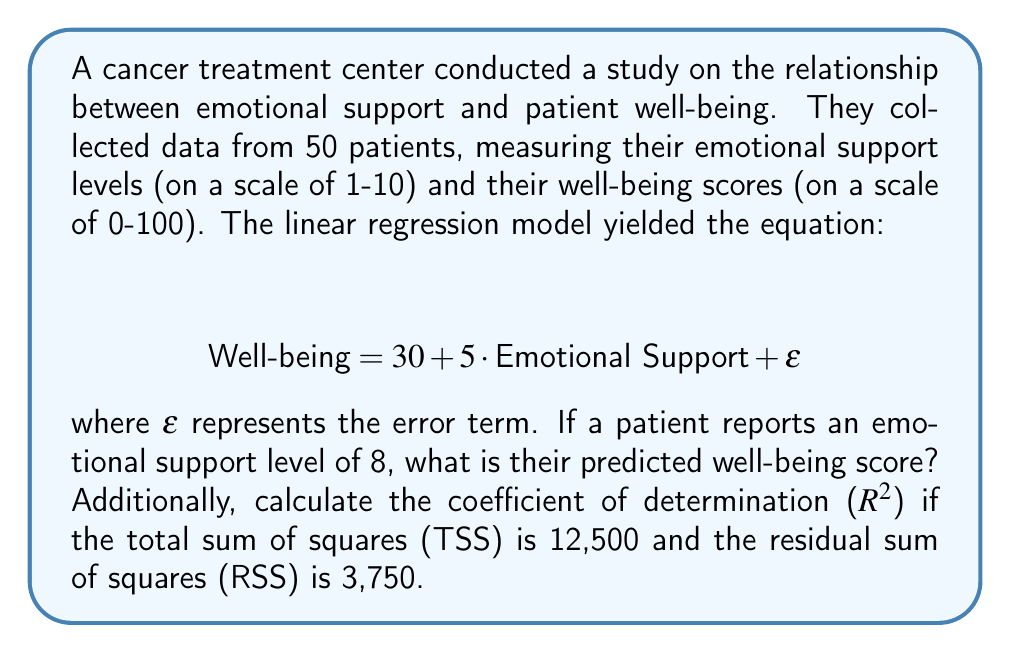Provide a solution to this math problem. Let's approach this problem step-by-step:

1) Predicted Well-being Score:
   The linear regression equation is given as:
   $$ \text{Well-being} = 30 + 5 \cdot \text{Emotional Support} + \epsilon $$

   For a patient with an emotional support level of 8, we can predict their well-being score by substituting this value:
   
   $$ \text{Well-being} = 30 + 5 \cdot 8 = 30 + 40 = 70 $$

2) Coefficient of Determination ($R^2$):
   The $R^2$ value represents the proportion of variance in the dependent variable (Well-being) that is predictable from the independent variable (Emotional Support).

   It is calculated using the formula:
   
   $$ R^2 = 1 - \frac{\text{RSS}}{\text{TSS}} $$

   Where:
   RSS = Residual Sum of Squares = 3,750
   TSS = Total Sum of Squares = 12,500

   Substituting these values:

   $$ R^2 = 1 - \frac{3,750}{12,500} = 1 - 0.3 = 0.7 $$

   This means that 70% of the variability in well-being scores can be explained by the emotional support levels.
Answer: Predicted well-being score: 70; $R^2 = 0.7$ 